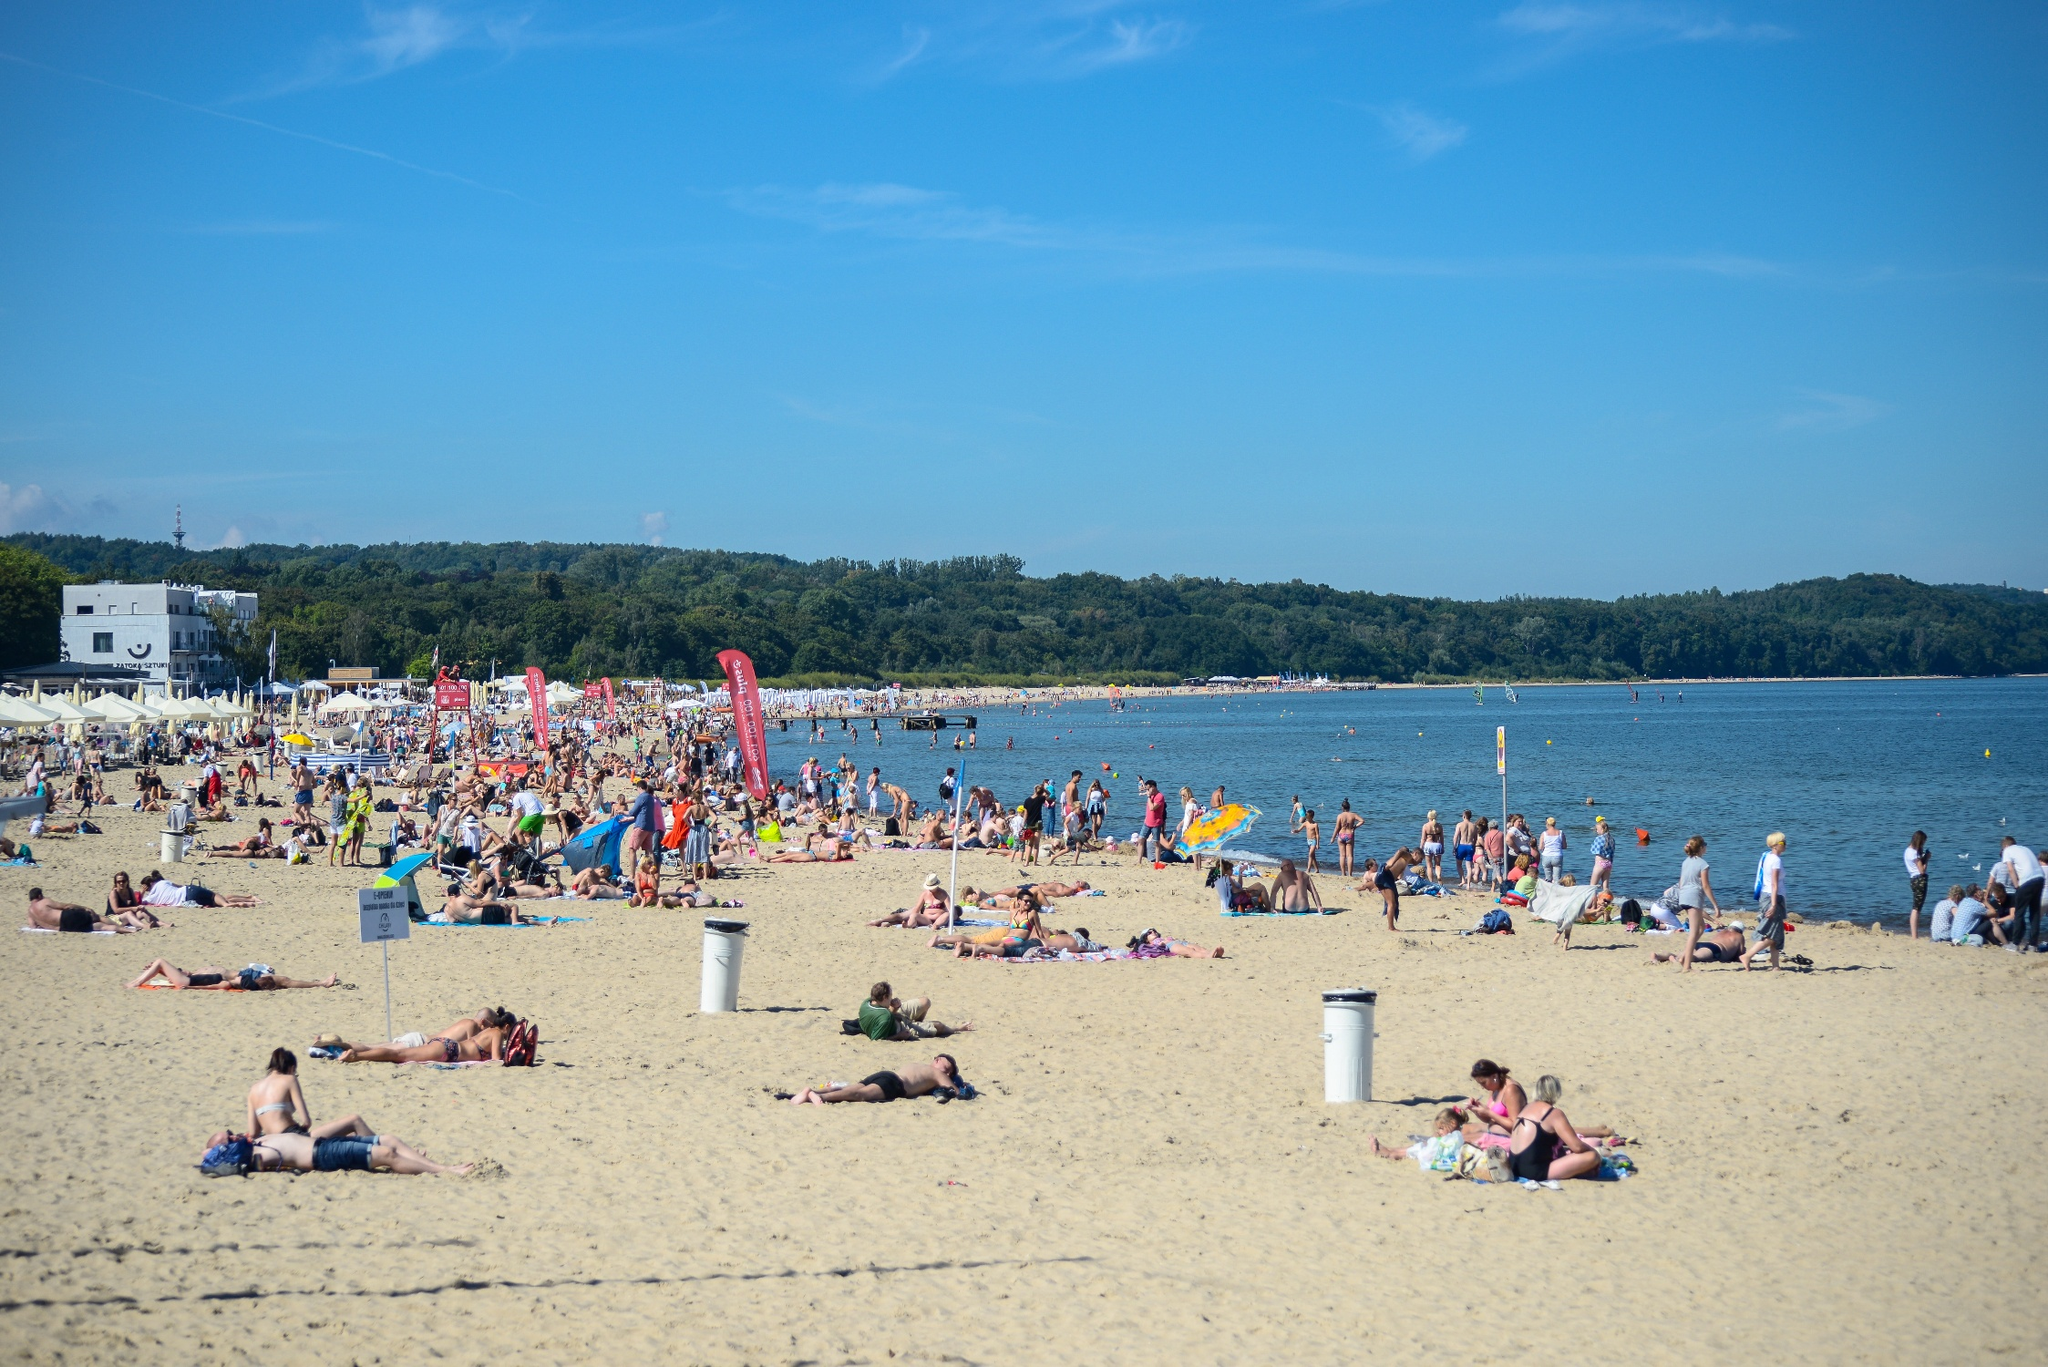What is the mood like on the beach today? The beach is buzzing with the lively and joyous atmosphere typical of a warm, sunny day. The crowd's relaxed postures and leisure activities suggest a collective mood of contentment and recreation. There's a sense of release from the daily grind as people soak up the sun, play, and connect with each other in the refreshing natural setting. 